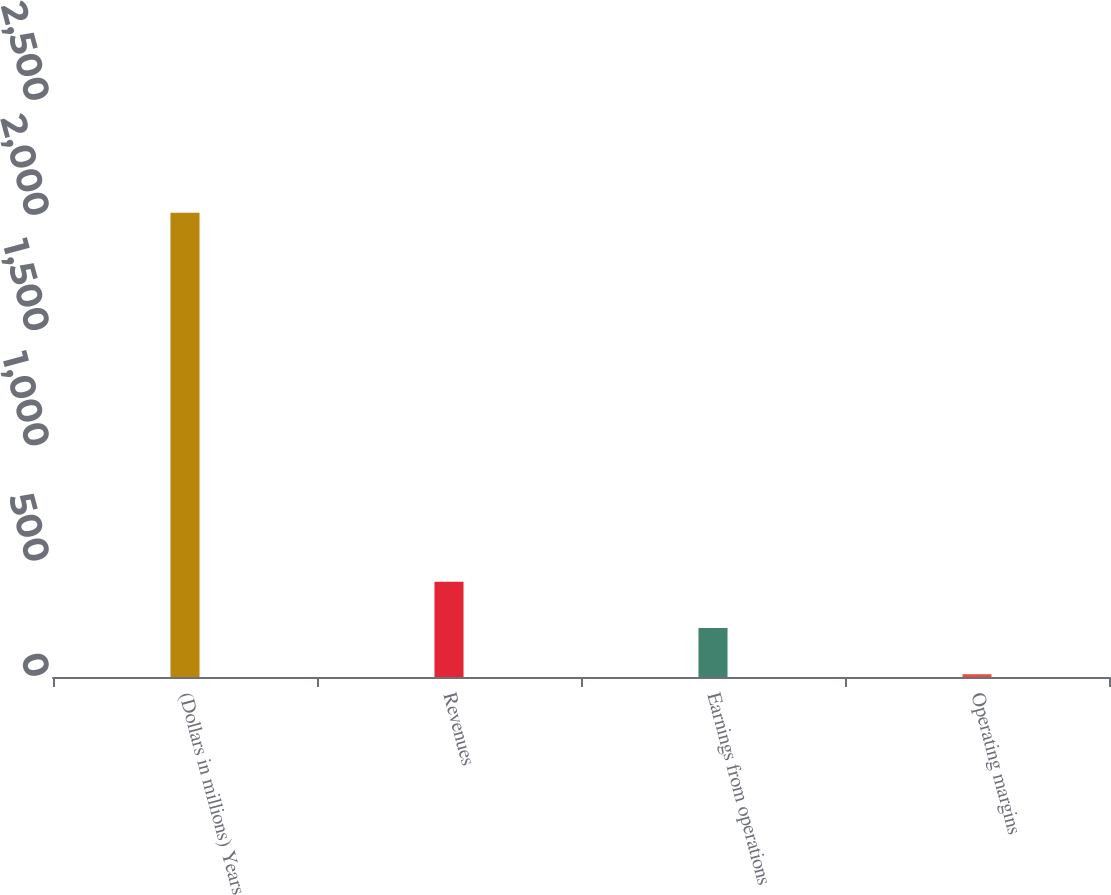Convert chart. <chart><loc_0><loc_0><loc_500><loc_500><bar_chart><fcel>(Dollars in millions) Years<fcel>Revenues<fcel>Earnings from operations<fcel>Operating margins<nl><fcel>2015<fcel>413<fcel>212.3<fcel>12<nl></chart> 